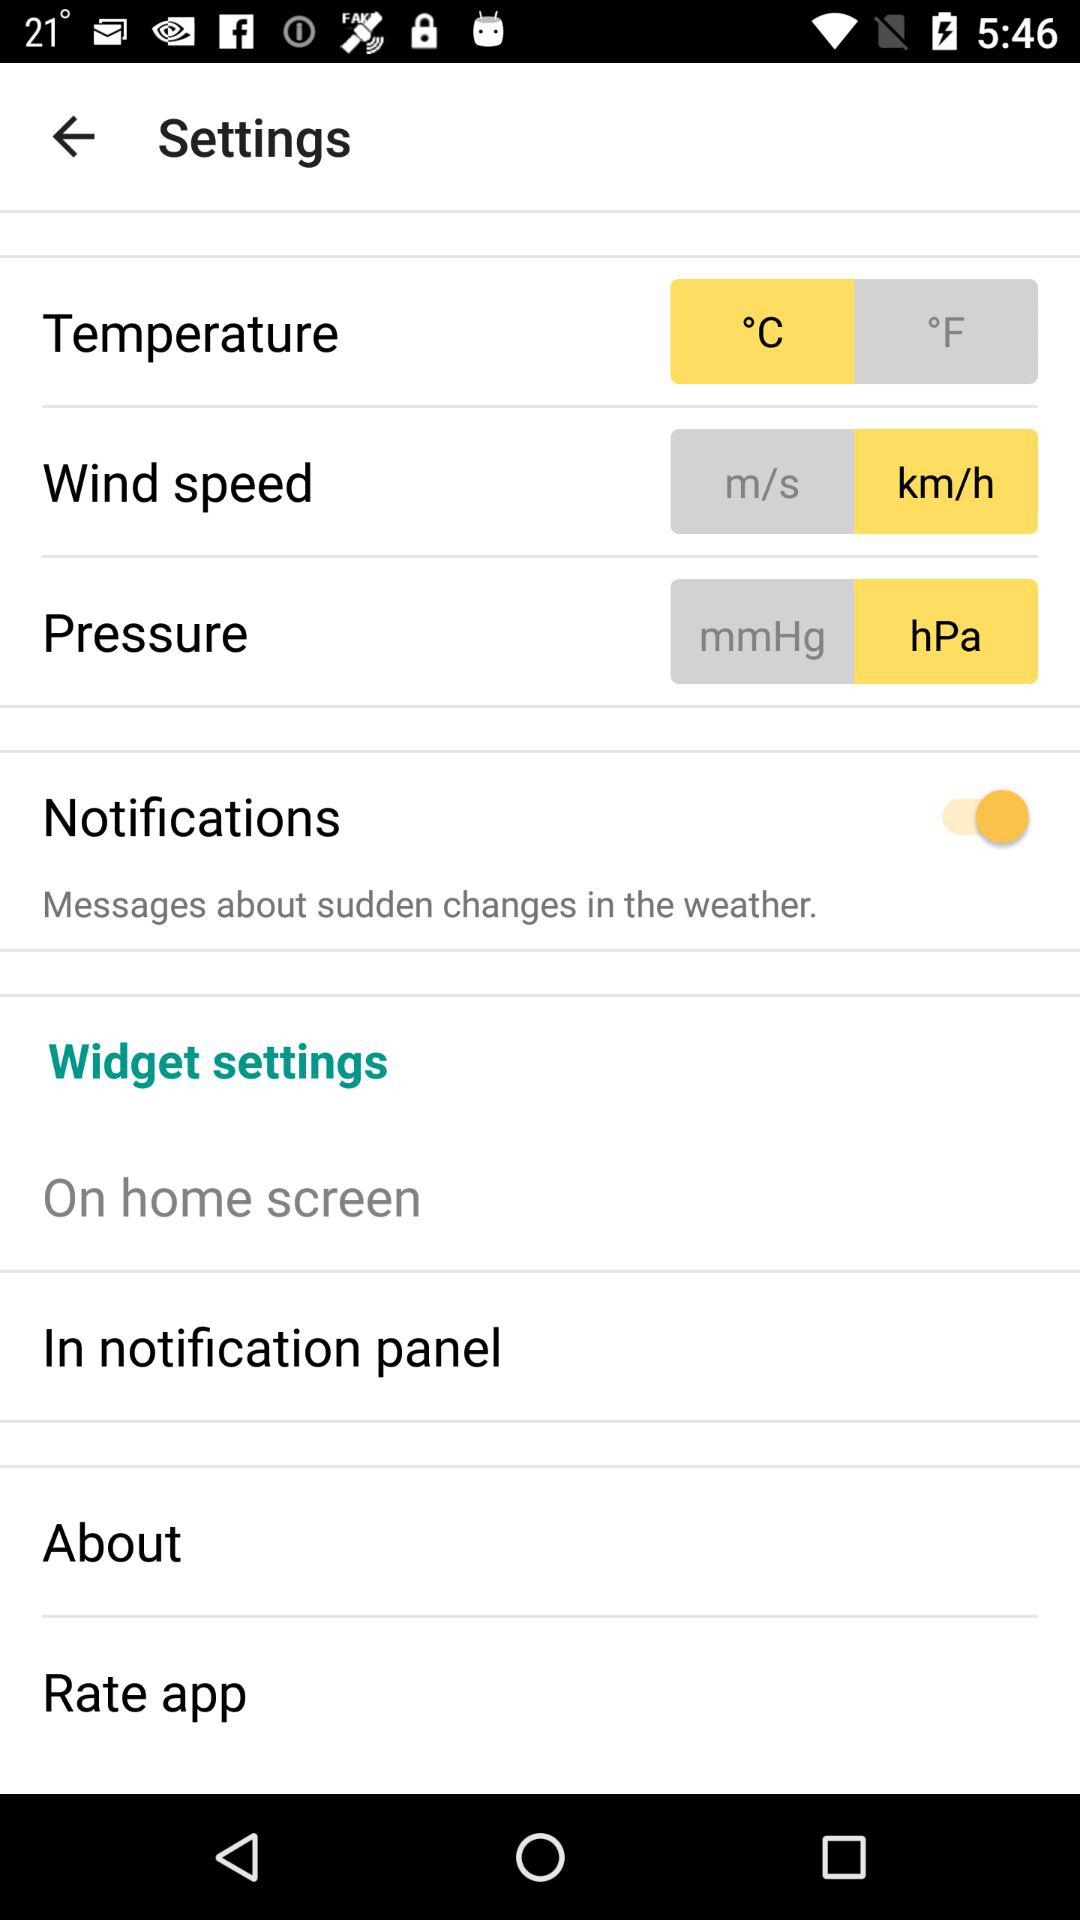What is the unit of pressure? The unit of pressure is hPa. 